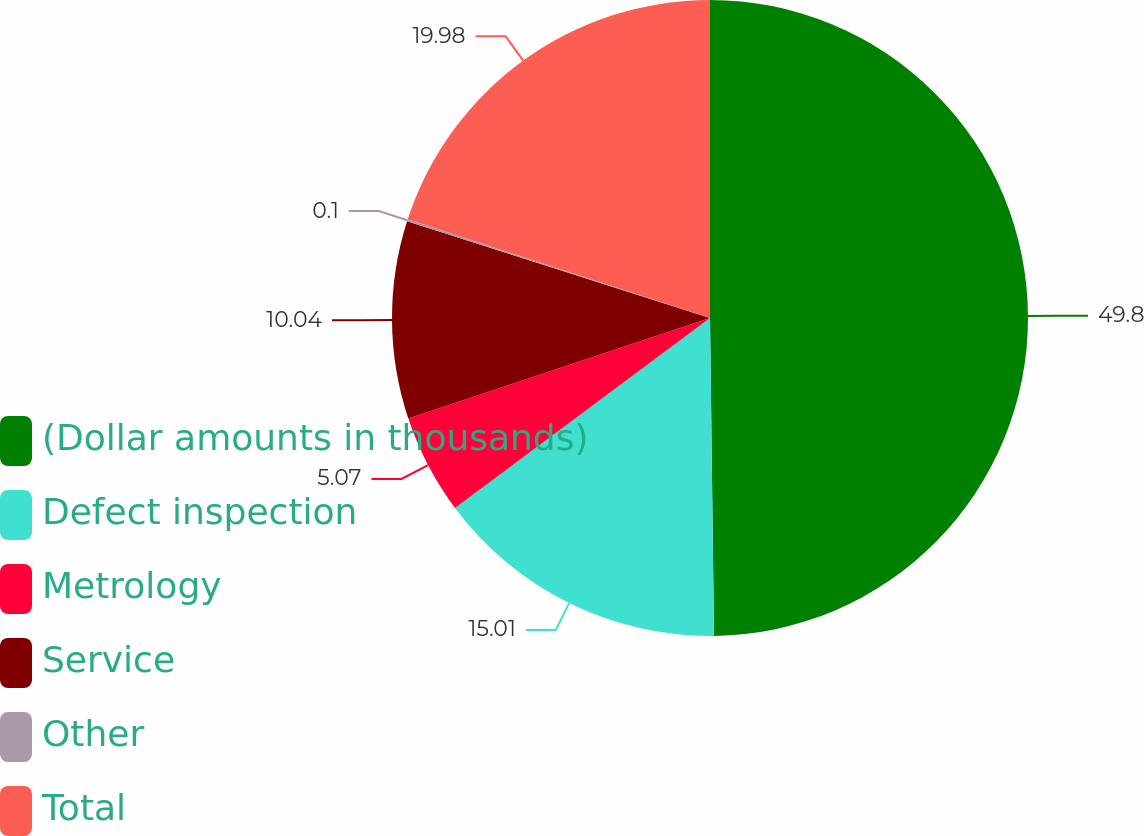Convert chart to OTSL. <chart><loc_0><loc_0><loc_500><loc_500><pie_chart><fcel>(Dollar amounts in thousands)<fcel>Defect inspection<fcel>Metrology<fcel>Service<fcel>Other<fcel>Total<nl><fcel>49.8%<fcel>15.01%<fcel>5.07%<fcel>10.04%<fcel>0.1%<fcel>19.98%<nl></chart> 